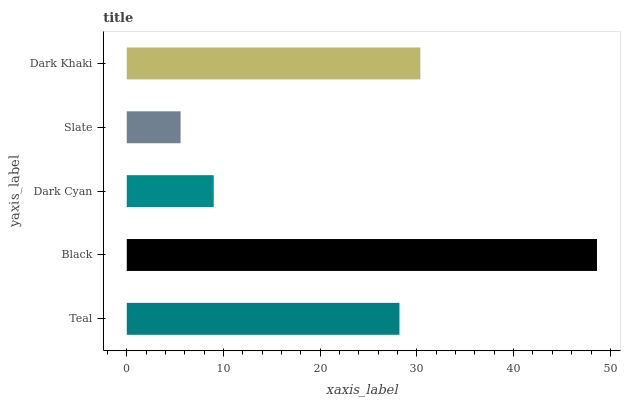Is Slate the minimum?
Answer yes or no. Yes. Is Black the maximum?
Answer yes or no. Yes. Is Dark Cyan the minimum?
Answer yes or no. No. Is Dark Cyan the maximum?
Answer yes or no. No. Is Black greater than Dark Cyan?
Answer yes or no. Yes. Is Dark Cyan less than Black?
Answer yes or no. Yes. Is Dark Cyan greater than Black?
Answer yes or no. No. Is Black less than Dark Cyan?
Answer yes or no. No. Is Teal the high median?
Answer yes or no. Yes. Is Teal the low median?
Answer yes or no. Yes. Is Black the high median?
Answer yes or no. No. Is Dark Cyan the low median?
Answer yes or no. No. 